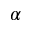Convert formula to latex. <formula><loc_0><loc_0><loc_500><loc_500>\alpha</formula> 